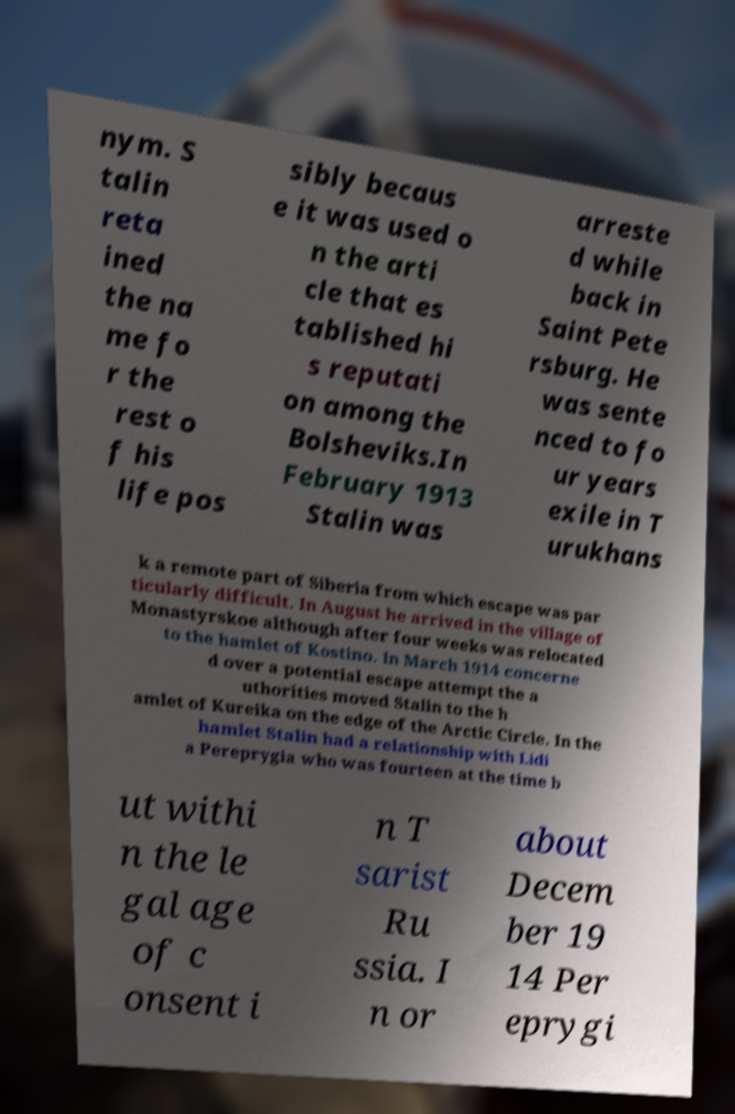Could you extract and type out the text from this image? nym. S talin reta ined the na me fo r the rest o f his life pos sibly becaus e it was used o n the arti cle that es tablished hi s reputati on among the Bolsheviks.In February 1913 Stalin was arreste d while back in Saint Pete rsburg. He was sente nced to fo ur years exile in T urukhans k a remote part of Siberia from which escape was par ticularly difficult. In August he arrived in the village of Monastyrskoe although after four weeks was relocated to the hamlet of Kostino. In March 1914 concerne d over a potential escape attempt the a uthorities moved Stalin to the h amlet of Kureika on the edge of the Arctic Circle. In the hamlet Stalin had a relationship with Lidi a Pereprygia who was fourteen at the time b ut withi n the le gal age of c onsent i n T sarist Ru ssia. I n or about Decem ber 19 14 Per eprygi 